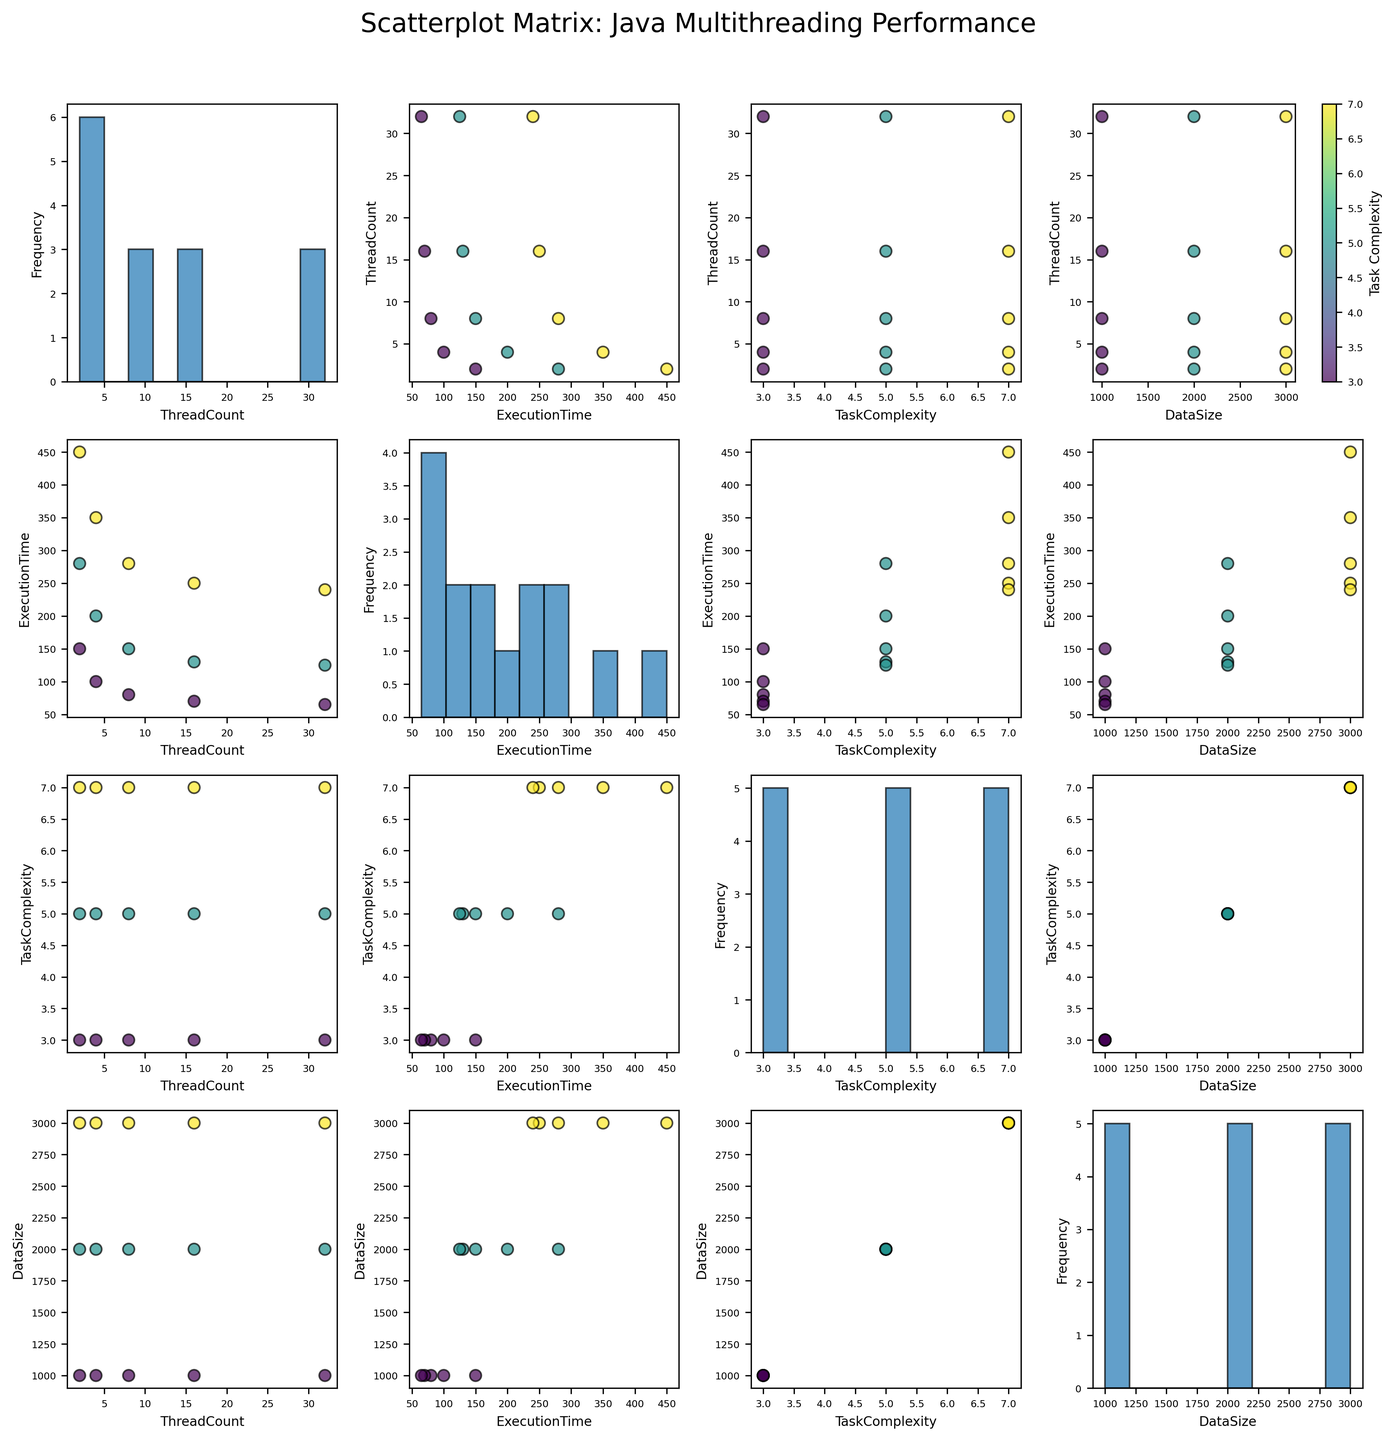Which variable is used to color the scatter plots? The scatter plots are colored using the "Task Complexity" variable. This can be seen in the color legend for Task Complexity on the right side of the plot.
Answer: Task Complexity How does the execution time change as the thread count increases, when Task Complexity is 3 and Data Size is 1000? Looking at the scatter plots where Task Complexity is 3 and Data Size is 1000, the execution time decreases as the thread count increases. Specifically, execution times go from 150 to 100, 80, 70, and 65 as thread count increases from 2 to 4, 8, 16, and 32, respectively.
Answer: Decreases Which plot axes contain histograms? Each diagonal plot in the scatterplot matrix contains a histogram. The histograms show the distribution of the variable that is plotted along the diagonal axis.
Answer: Diagonal plots Compare the execution times for Task Complexity 5 with Data Size 2000 when thread count is 2 and 4. Which thread count has a lower execution time? In the scatter plots, for Task Complexity 5 and Data Size 2000, thread count 2 has an execution time of 280, while thread count 4 has an execution time of 200. Therefore, thread count 4 has a lower execution time.
Answer: Thread count 4 Is the execution time consistently decreasing with increasing thread count for Task Complexity 7 and Data Size 3000? In the scatter plots for Task Complexity 7 and Data Size 3000, the execution times decrease as thread counts increase from 2 to 4, and from 4 to 8. However, from thread count 8 to 16 to 32, the reduction in execution time is minimal (280 to 250 to 240). Hence, the decrease is not strictly consistent but shows a trend of diminishing returns.
Answer: No How does Task Complexity affect the overall execution time, based on the scatterplot matrix? From the scatterplot matrix, it is observed that higher Task Complexity values are generally associated with longer execution times. This can be seen from the color gradient across the plots. For higher Task Complexity values, execution times are generally higher across different thread counts and data sizes.
Answer: Higher Task Complexity leads to longer execution times 